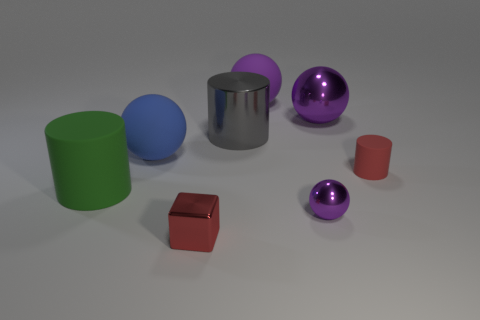Are there more matte cylinders than big purple rubber cylinders?
Keep it short and to the point. Yes. What number of metal spheres have the same size as the red matte object?
Offer a very short reply. 1. There is a rubber thing that is the same color as the tiny metal sphere; what shape is it?
Make the answer very short. Sphere. What number of things are spheres behind the metallic cylinder or purple matte balls?
Provide a short and direct response. 2. Are there fewer purple shiny things than metal cubes?
Give a very brief answer. No. There is a large thing that is made of the same material as the big gray cylinder; what shape is it?
Make the answer very short. Sphere. There is a tiny shiny sphere; are there any tiny cylinders right of it?
Make the answer very short. Yes. Is the number of purple balls behind the red matte cylinder less than the number of small blocks?
Ensure brevity in your answer.  No. What is the green cylinder made of?
Provide a succinct answer. Rubber. The tiny cube is what color?
Offer a very short reply. Red. 